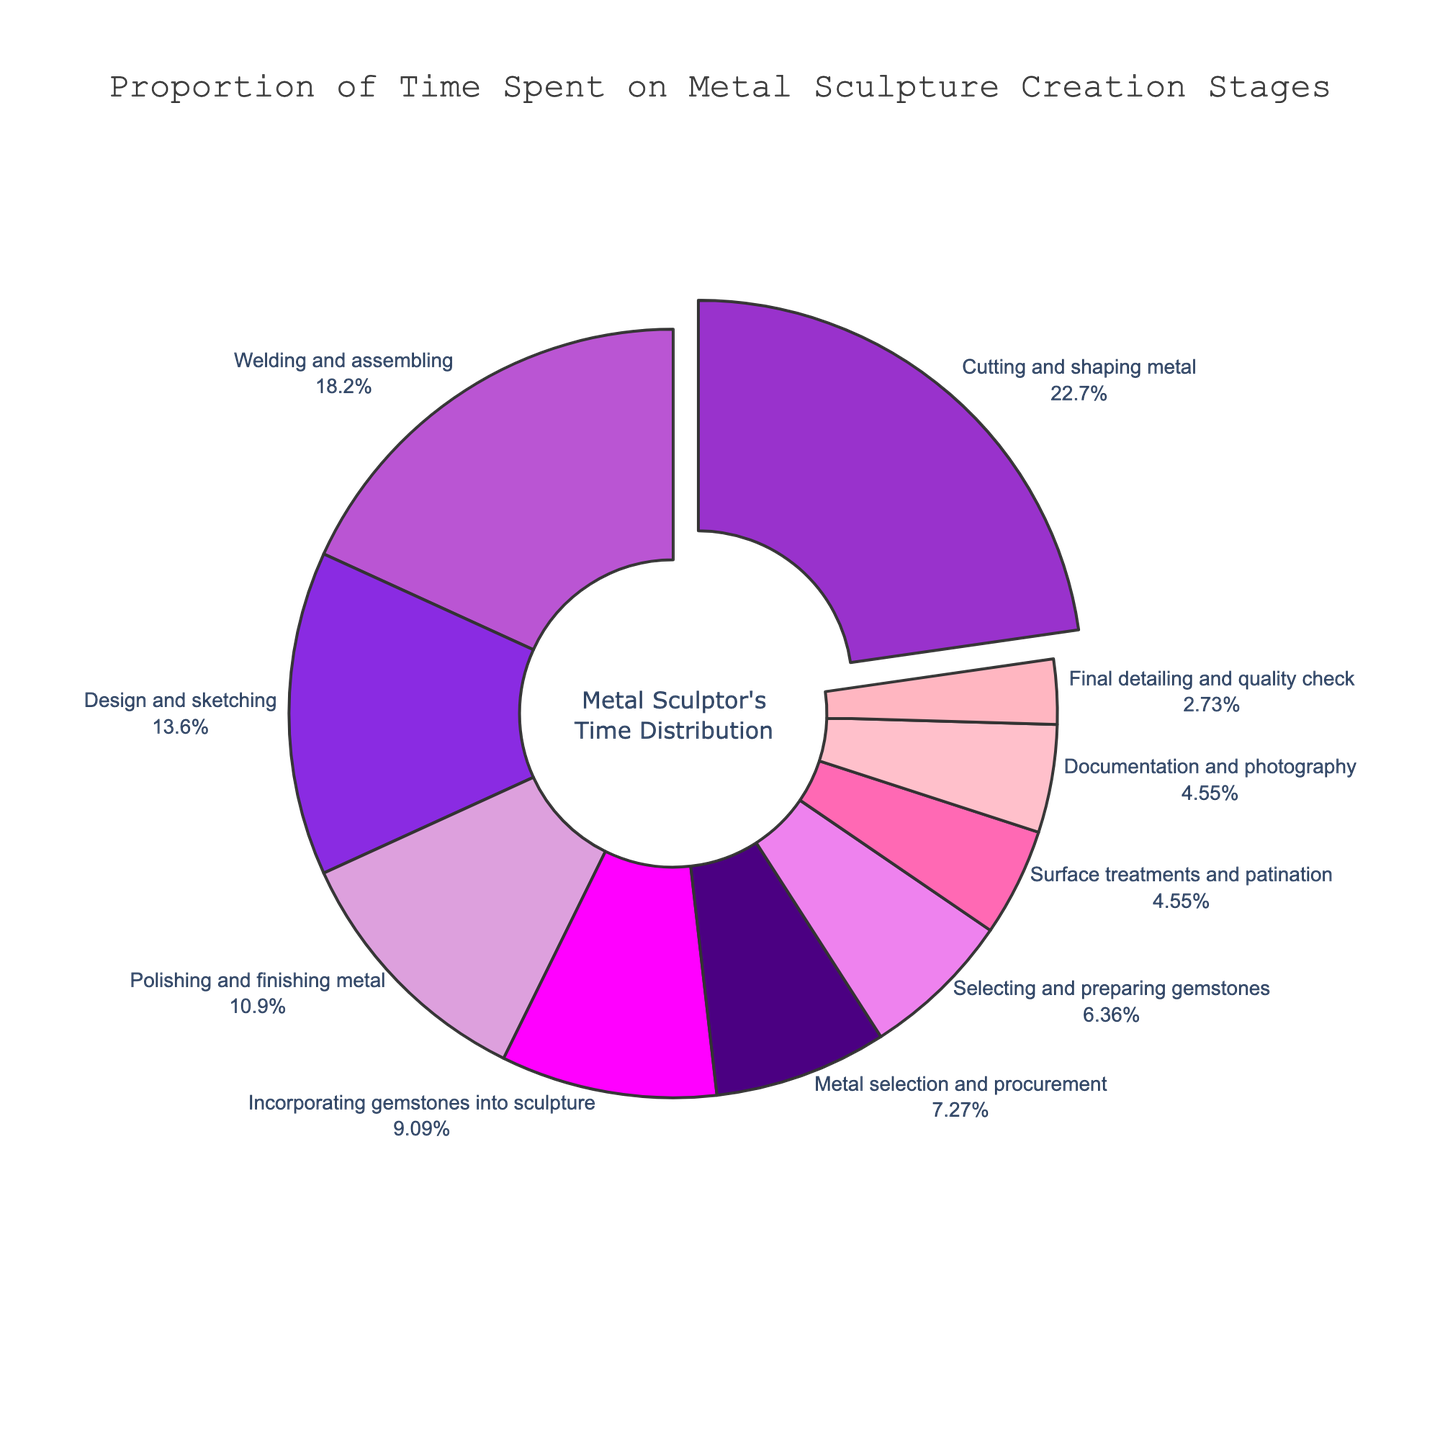What stage takes the highest proportion of time in the creation process? The stage with the highest percentage is Cutting and shaping metal.
Answer: Cutting and shaping metal How much more time is spent on Cutting and shaping metal compared to Selecting and preparing gemstones? Time spent on Cutting and shaping metal is 25%, and Selecting and preparing gemstones is 7%. The difference is 25% - 7% = 18%.
Answer: 18% What's the sum of the time spent on Welding and assembling, Polishing and finishing metal, and Final detailing and quality check? The percentages for Welding and assembling, Polishing and finishing metal, and Final detailing and quality check are 20%, 12%, and 3%, respectively. The sum is 20% + 12% + 3% = 35%.
Answer: 35% Which stage has the smallest proportion of time, and what is its percentage? Final detailing and quality check has the smallest proportion of 3%.
Answer: Final detailing and quality check, 3% Compare the time spent on Documentation and photography to the time spent on Surface treatments and patination. Which one is higher? Documentation and photography has a percentage of 5%, and so does Surface treatments and patination. They are equal.
Answer: They are equal What stages together account for exactly 27% of the total time? Selecting and preparing gemstones (7%) and Incorporating gemstones into sculpture (10%) sum to 17%. Adding Metal selection and procurement (8%) results in 25%. So, adding Final detailing and quality check (3%) totals 28%, but breaking it down to account for exactly 27% is not directly feasible with given percentages.
Answer: Not feasible What is the combined percentage of stages related to gemstones? Selecting and preparing gemstones is 7% and Incorporating gemstones into sculpture is 10%. The combined percentage is 7% + 10% = 17%.
Answer: 17% What is the difference in percentage between Polishing and finishing metal and Documentation and photography? Polishing and finishing metal is at 12% and Documentation and photography is at 5%. The difference is 12% - 5% = 7%.
Answer: 7% 